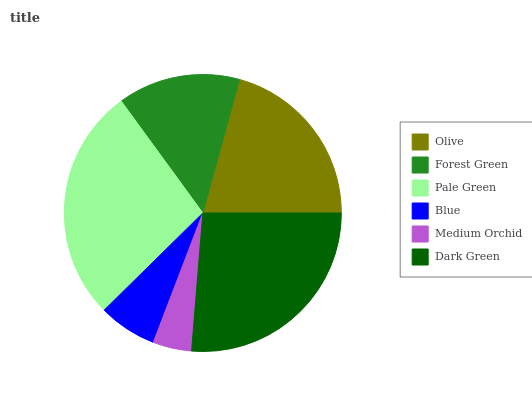Is Medium Orchid the minimum?
Answer yes or no. Yes. Is Pale Green the maximum?
Answer yes or no. Yes. Is Forest Green the minimum?
Answer yes or no. No. Is Forest Green the maximum?
Answer yes or no. No. Is Olive greater than Forest Green?
Answer yes or no. Yes. Is Forest Green less than Olive?
Answer yes or no. Yes. Is Forest Green greater than Olive?
Answer yes or no. No. Is Olive less than Forest Green?
Answer yes or no. No. Is Olive the high median?
Answer yes or no. Yes. Is Forest Green the low median?
Answer yes or no. Yes. Is Pale Green the high median?
Answer yes or no. No. Is Dark Green the low median?
Answer yes or no. No. 